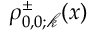<formula> <loc_0><loc_0><loc_500><loc_500>\rho _ { 0 , 0 ; \ m a t h s c r { k } } ^ { \pm } ( x )</formula> 